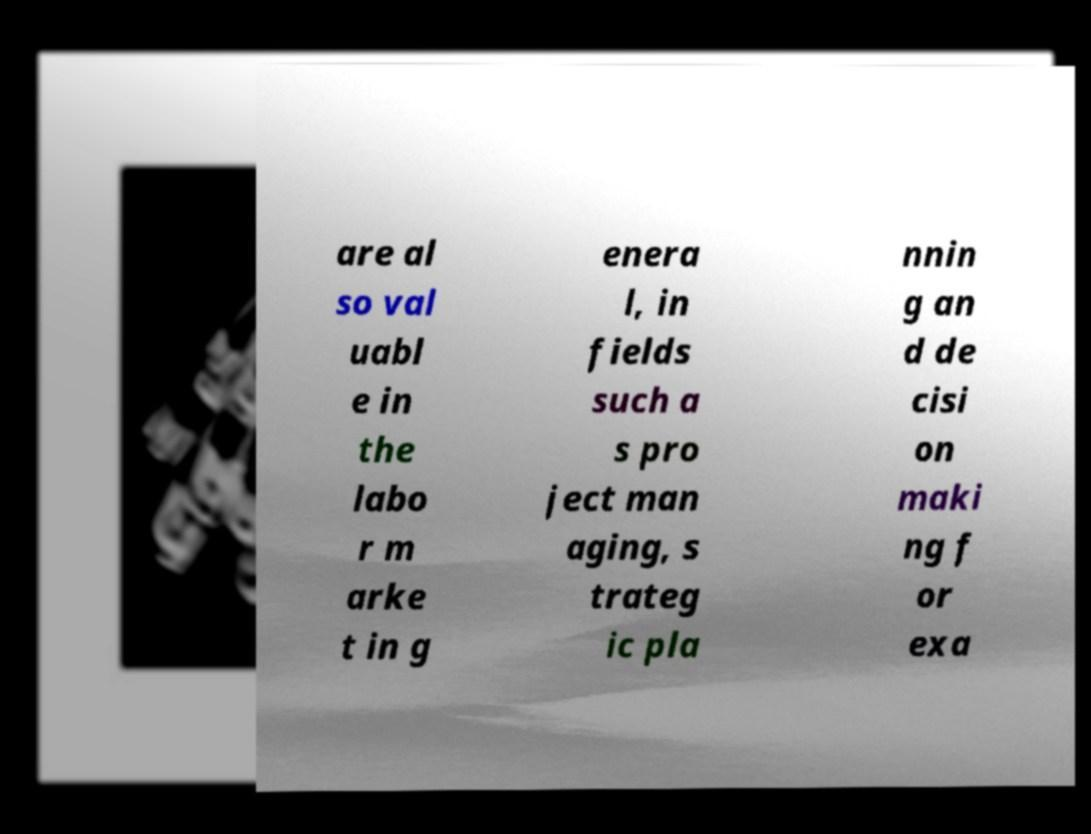There's text embedded in this image that I need extracted. Can you transcribe it verbatim? are al so val uabl e in the labo r m arke t in g enera l, in fields such a s pro ject man aging, s trateg ic pla nnin g an d de cisi on maki ng f or exa 